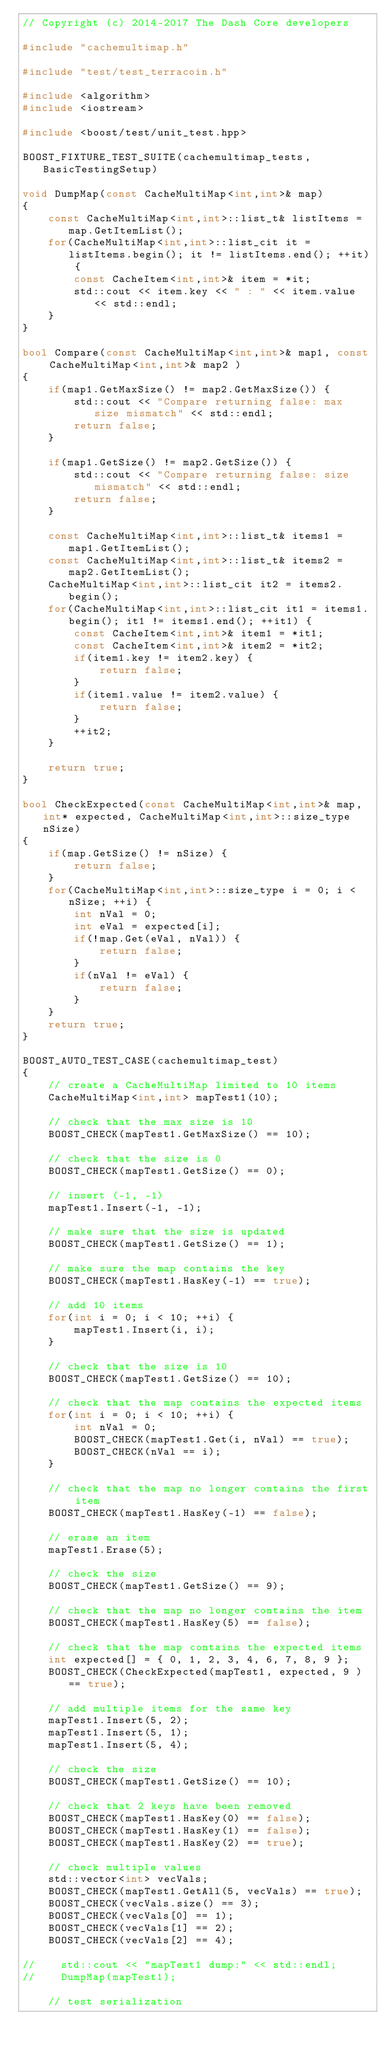<code> <loc_0><loc_0><loc_500><loc_500><_C++_>// Copyright (c) 2014-2017 The Dash Core developers

#include "cachemultimap.h"

#include "test/test_terracoin.h"

#include <algorithm>
#include <iostream>

#include <boost/test/unit_test.hpp>

BOOST_FIXTURE_TEST_SUITE(cachemultimap_tests, BasicTestingSetup)

void DumpMap(const CacheMultiMap<int,int>& map)
{
    const CacheMultiMap<int,int>::list_t& listItems = map.GetItemList();
    for(CacheMultiMap<int,int>::list_cit it = listItems.begin(); it != listItems.end(); ++it) {
        const CacheItem<int,int>& item = *it;
        std::cout << item.key << " : " << item.value << std::endl;
    }
}

bool Compare(const CacheMultiMap<int,int>& map1, const CacheMultiMap<int,int>& map2 )
{
    if(map1.GetMaxSize() != map2.GetMaxSize()) {
        std::cout << "Compare returning false: max size mismatch" << std::endl;
        return false;
    }

    if(map1.GetSize() != map2.GetSize()) {
        std::cout << "Compare returning false: size mismatch" << std::endl;
        return false;
    }

    const CacheMultiMap<int,int>::list_t& items1 = map1.GetItemList();
    const CacheMultiMap<int,int>::list_t& items2 = map2.GetItemList();
    CacheMultiMap<int,int>::list_cit it2 = items2.begin();
    for(CacheMultiMap<int,int>::list_cit it1 = items1.begin(); it1 != items1.end(); ++it1) {
        const CacheItem<int,int>& item1 = *it1;
        const CacheItem<int,int>& item2 = *it2;
        if(item1.key != item2.key) {
            return false;
        }
        if(item1.value != item2.value) {
            return false;
        }
        ++it2;
    }

    return true;
}

bool CheckExpected(const CacheMultiMap<int,int>& map, int* expected, CacheMultiMap<int,int>::size_type nSize)
{
    if(map.GetSize() != nSize) {
        return false;
    }
    for(CacheMultiMap<int,int>::size_type i = 0; i < nSize; ++i) {
        int nVal = 0;
        int eVal = expected[i];
        if(!map.Get(eVal, nVal)) {
            return false;
        }
        if(nVal != eVal) {
            return false;
        }
    }
    return true;
}

BOOST_AUTO_TEST_CASE(cachemultimap_test)
{
    // create a CacheMultiMap limited to 10 items
    CacheMultiMap<int,int> mapTest1(10);

    // check that the max size is 10
    BOOST_CHECK(mapTest1.GetMaxSize() == 10);

    // check that the size is 0
    BOOST_CHECK(mapTest1.GetSize() == 0);

    // insert (-1, -1)
    mapTest1.Insert(-1, -1);

    // make sure that the size is updated
    BOOST_CHECK(mapTest1.GetSize() == 1);

    // make sure the map contains the key
    BOOST_CHECK(mapTest1.HasKey(-1) == true);

    // add 10 items
    for(int i = 0; i < 10; ++i) {
        mapTest1.Insert(i, i);
    }

    // check that the size is 10
    BOOST_CHECK(mapTest1.GetSize() == 10);

    // check that the map contains the expected items
    for(int i = 0; i < 10; ++i) {
        int nVal = 0;
        BOOST_CHECK(mapTest1.Get(i, nVal) == true);
        BOOST_CHECK(nVal == i);
    }

    // check that the map no longer contains the first item
    BOOST_CHECK(mapTest1.HasKey(-1) == false);

    // erase an item
    mapTest1.Erase(5);

    // check the size
    BOOST_CHECK(mapTest1.GetSize() == 9);

    // check that the map no longer contains the item
    BOOST_CHECK(mapTest1.HasKey(5) == false);

    // check that the map contains the expected items
    int expected[] = { 0, 1, 2, 3, 4, 6, 7, 8, 9 };
    BOOST_CHECK(CheckExpected(mapTest1, expected, 9 ) == true);

    // add multiple items for the same key
    mapTest1.Insert(5, 2);
    mapTest1.Insert(5, 1);
    mapTest1.Insert(5, 4);

    // check the size
    BOOST_CHECK(mapTest1.GetSize() == 10);

    // check that 2 keys have been removed
    BOOST_CHECK(mapTest1.HasKey(0) == false);
    BOOST_CHECK(mapTest1.HasKey(1) == false);
    BOOST_CHECK(mapTest1.HasKey(2) == true);

    // check multiple values
    std::vector<int> vecVals;
    BOOST_CHECK(mapTest1.GetAll(5, vecVals) == true);
    BOOST_CHECK(vecVals.size() == 3);
    BOOST_CHECK(vecVals[0] == 1);
    BOOST_CHECK(vecVals[1] == 2);
    BOOST_CHECK(vecVals[2] == 4);

//    std::cout << "mapTest1 dump:" << std::endl;
//    DumpMap(mapTest1);

    // test serialization</code> 